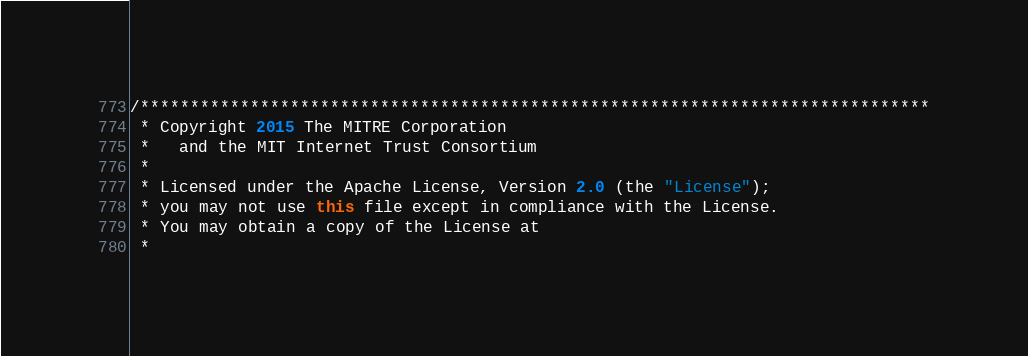<code> <loc_0><loc_0><loc_500><loc_500><_Java_>/*******************************************************************************
 * Copyright 2015 The MITRE Corporation
 *   and the MIT Internet Trust Consortium
 *
 * Licensed under the Apache License, Version 2.0 (the "License");
 * you may not use this file except in compliance with the License.
 * You may obtain a copy of the License at
 *</code> 